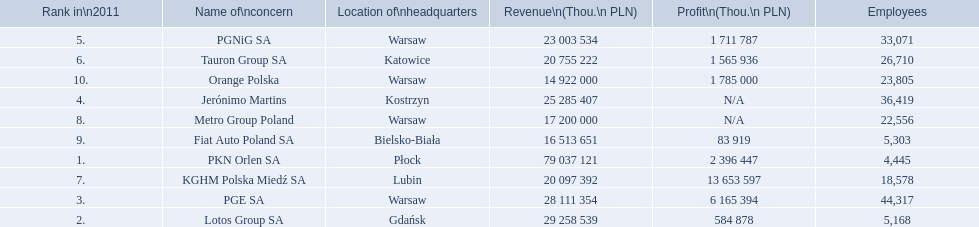What are the names of the major companies of poland? PKN Orlen SA, Lotos Group SA, PGE SA, Jerónimo Martins, PGNiG SA, Tauron Group SA, KGHM Polska Miedź SA, Metro Group Poland, Fiat Auto Poland SA, Orange Polska. What are the revenues of those companies in thou. pln? PKN Orlen SA, 79 037 121, Lotos Group SA, 29 258 539, PGE SA, 28 111 354, Jerónimo Martins, 25 285 407, PGNiG SA, 23 003 534, Tauron Group SA, 20 755 222, KGHM Polska Miedź SA, 20 097 392, Metro Group Poland, 17 200 000, Fiat Auto Poland SA, 16 513 651, Orange Polska, 14 922 000. Which of these revenues is greater than 75 000 000 thou. pln? 79 037 121. Which company has a revenue equal to 79 037 121 thou pln? PKN Orlen SA. 